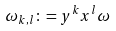<formula> <loc_0><loc_0><loc_500><loc_500>\omega _ { k , l } \colon = y ^ { k } x ^ { l } \omega</formula> 